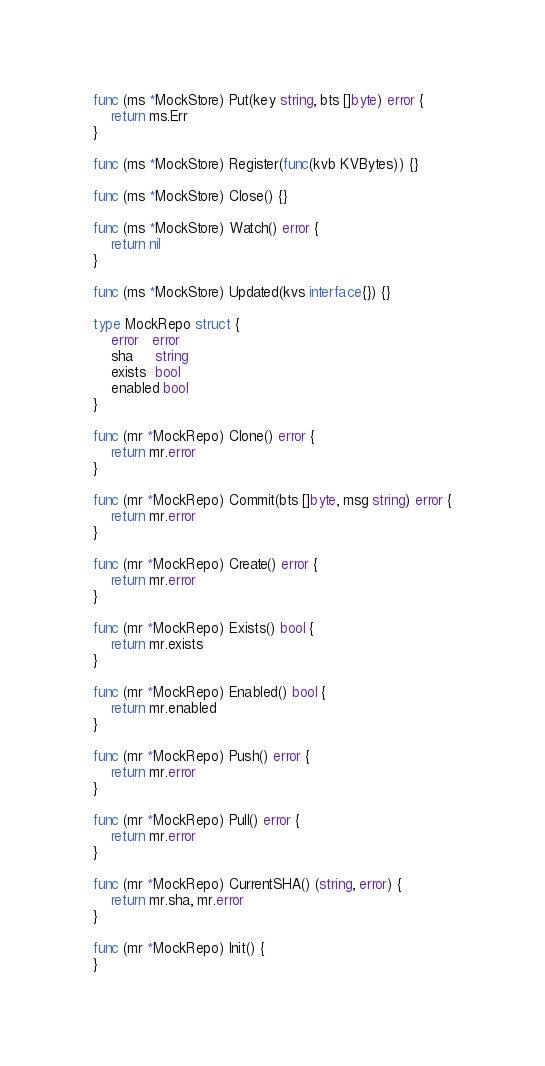<code> <loc_0><loc_0><loc_500><loc_500><_Go_>func (ms *MockStore) Put(key string, bts []byte) error {
	return ms.Err
}

func (ms *MockStore) Register(func(kvb KVBytes)) {}

func (ms *MockStore) Close() {}

func (ms *MockStore) Watch() error {
	return nil
}

func (ms *MockStore) Updated(kvs interface{}) {}

type MockRepo struct {
	error   error
	sha     string
	exists  bool
	enabled bool
}

func (mr *MockRepo) Clone() error {
	return mr.error
}

func (mr *MockRepo) Commit(bts []byte, msg string) error {
	return mr.error
}

func (mr *MockRepo) Create() error {
	return mr.error
}

func (mr *MockRepo) Exists() bool {
	return mr.exists
}

func (mr *MockRepo) Enabled() bool {
	return mr.enabled
}

func (mr *MockRepo) Push() error {
	return mr.error
}

func (mr *MockRepo) Pull() error {
	return mr.error
}

func (mr *MockRepo) CurrentSHA() (string, error) {
	return mr.sha, mr.error
}

func (mr *MockRepo) Init() {
}
</code> 